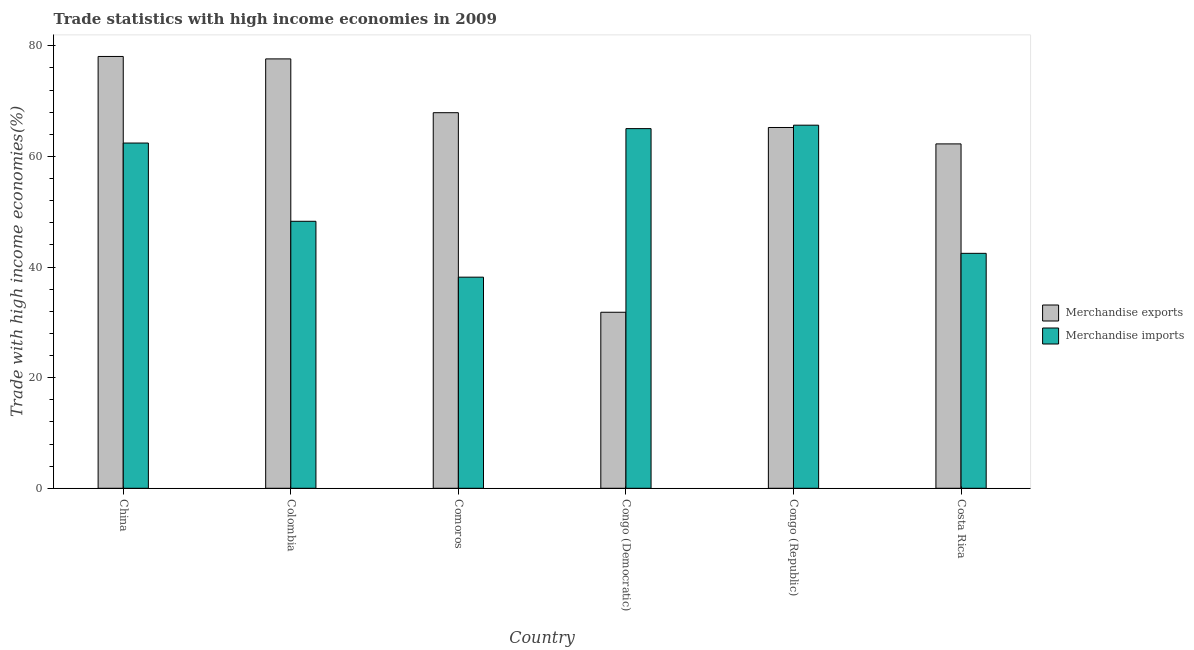How many different coloured bars are there?
Offer a very short reply. 2. How many groups of bars are there?
Your answer should be very brief. 6. Are the number of bars on each tick of the X-axis equal?
Offer a very short reply. Yes. In how many cases, is the number of bars for a given country not equal to the number of legend labels?
Offer a very short reply. 0. What is the merchandise exports in Costa Rica?
Give a very brief answer. 62.27. Across all countries, what is the maximum merchandise exports?
Make the answer very short. 78.08. Across all countries, what is the minimum merchandise imports?
Your answer should be compact. 38.18. In which country was the merchandise imports maximum?
Offer a terse response. Congo (Republic). In which country was the merchandise exports minimum?
Your answer should be very brief. Congo (Democratic). What is the total merchandise exports in the graph?
Make the answer very short. 382.99. What is the difference between the merchandise exports in Comoros and that in Congo (Republic)?
Keep it short and to the point. 2.68. What is the difference between the merchandise imports in Congo (Republic) and the merchandise exports in Comoros?
Offer a very short reply. -2.26. What is the average merchandise exports per country?
Give a very brief answer. 63.83. What is the difference between the merchandise imports and merchandise exports in Colombia?
Your answer should be compact. -29.36. What is the ratio of the merchandise imports in China to that in Comoros?
Your answer should be compact. 1.64. What is the difference between the highest and the second highest merchandise imports?
Give a very brief answer. 0.62. What is the difference between the highest and the lowest merchandise exports?
Your answer should be very brief. 46.25. In how many countries, is the merchandise imports greater than the average merchandise imports taken over all countries?
Make the answer very short. 3. What does the 2nd bar from the right in Congo (Republic) represents?
Ensure brevity in your answer.  Merchandise exports. How many bars are there?
Provide a succinct answer. 12. Are all the bars in the graph horizontal?
Your response must be concise. No. What is the difference between two consecutive major ticks on the Y-axis?
Give a very brief answer. 20. Are the values on the major ticks of Y-axis written in scientific E-notation?
Provide a succinct answer. No. Does the graph contain any zero values?
Your answer should be very brief. No. Does the graph contain grids?
Give a very brief answer. No. How are the legend labels stacked?
Provide a succinct answer. Vertical. What is the title of the graph?
Keep it short and to the point. Trade statistics with high income economies in 2009. Does "Revenue" appear as one of the legend labels in the graph?
Make the answer very short. No. What is the label or title of the X-axis?
Provide a short and direct response. Country. What is the label or title of the Y-axis?
Provide a short and direct response. Trade with high income economies(%). What is the Trade with high income economies(%) of Merchandise exports in China?
Ensure brevity in your answer.  78.08. What is the Trade with high income economies(%) of Merchandise imports in China?
Ensure brevity in your answer.  62.43. What is the Trade with high income economies(%) in Merchandise exports in Colombia?
Make the answer very short. 77.64. What is the Trade with high income economies(%) in Merchandise imports in Colombia?
Your answer should be compact. 48.28. What is the Trade with high income economies(%) in Merchandise exports in Comoros?
Your answer should be very brief. 67.92. What is the Trade with high income economies(%) of Merchandise imports in Comoros?
Your answer should be compact. 38.18. What is the Trade with high income economies(%) of Merchandise exports in Congo (Democratic)?
Make the answer very short. 31.83. What is the Trade with high income economies(%) in Merchandise imports in Congo (Democratic)?
Your answer should be very brief. 65.04. What is the Trade with high income economies(%) in Merchandise exports in Congo (Republic)?
Your answer should be compact. 65.24. What is the Trade with high income economies(%) of Merchandise imports in Congo (Republic)?
Your answer should be compact. 65.66. What is the Trade with high income economies(%) of Merchandise exports in Costa Rica?
Offer a very short reply. 62.27. What is the Trade with high income economies(%) in Merchandise imports in Costa Rica?
Keep it short and to the point. 42.48. Across all countries, what is the maximum Trade with high income economies(%) in Merchandise exports?
Provide a short and direct response. 78.08. Across all countries, what is the maximum Trade with high income economies(%) in Merchandise imports?
Provide a succinct answer. 65.66. Across all countries, what is the minimum Trade with high income economies(%) in Merchandise exports?
Ensure brevity in your answer.  31.83. Across all countries, what is the minimum Trade with high income economies(%) of Merchandise imports?
Your answer should be very brief. 38.18. What is the total Trade with high income economies(%) in Merchandise exports in the graph?
Your answer should be compact. 382.99. What is the total Trade with high income economies(%) of Merchandise imports in the graph?
Keep it short and to the point. 322.07. What is the difference between the Trade with high income economies(%) in Merchandise exports in China and that in Colombia?
Ensure brevity in your answer.  0.44. What is the difference between the Trade with high income economies(%) of Merchandise imports in China and that in Colombia?
Offer a very short reply. 14.15. What is the difference between the Trade with high income economies(%) of Merchandise exports in China and that in Comoros?
Your answer should be very brief. 10.17. What is the difference between the Trade with high income economies(%) in Merchandise imports in China and that in Comoros?
Ensure brevity in your answer.  24.25. What is the difference between the Trade with high income economies(%) in Merchandise exports in China and that in Congo (Democratic)?
Your response must be concise. 46.25. What is the difference between the Trade with high income economies(%) in Merchandise imports in China and that in Congo (Democratic)?
Ensure brevity in your answer.  -2.61. What is the difference between the Trade with high income economies(%) in Merchandise exports in China and that in Congo (Republic)?
Your answer should be very brief. 12.84. What is the difference between the Trade with high income economies(%) in Merchandise imports in China and that in Congo (Republic)?
Your response must be concise. -3.23. What is the difference between the Trade with high income economies(%) of Merchandise exports in China and that in Costa Rica?
Make the answer very short. 15.81. What is the difference between the Trade with high income economies(%) in Merchandise imports in China and that in Costa Rica?
Offer a very short reply. 19.95. What is the difference between the Trade with high income economies(%) of Merchandise exports in Colombia and that in Comoros?
Your answer should be very brief. 9.73. What is the difference between the Trade with high income economies(%) in Merchandise imports in Colombia and that in Comoros?
Make the answer very short. 10.1. What is the difference between the Trade with high income economies(%) in Merchandise exports in Colombia and that in Congo (Democratic)?
Keep it short and to the point. 45.81. What is the difference between the Trade with high income economies(%) of Merchandise imports in Colombia and that in Congo (Democratic)?
Offer a very short reply. -16.76. What is the difference between the Trade with high income economies(%) in Merchandise exports in Colombia and that in Congo (Republic)?
Your answer should be compact. 12.4. What is the difference between the Trade with high income economies(%) in Merchandise imports in Colombia and that in Congo (Republic)?
Make the answer very short. -17.38. What is the difference between the Trade with high income economies(%) of Merchandise exports in Colombia and that in Costa Rica?
Keep it short and to the point. 15.37. What is the difference between the Trade with high income economies(%) of Merchandise imports in Colombia and that in Costa Rica?
Provide a succinct answer. 5.8. What is the difference between the Trade with high income economies(%) in Merchandise exports in Comoros and that in Congo (Democratic)?
Give a very brief answer. 36.08. What is the difference between the Trade with high income economies(%) of Merchandise imports in Comoros and that in Congo (Democratic)?
Make the answer very short. -26.86. What is the difference between the Trade with high income economies(%) in Merchandise exports in Comoros and that in Congo (Republic)?
Give a very brief answer. 2.68. What is the difference between the Trade with high income economies(%) of Merchandise imports in Comoros and that in Congo (Republic)?
Give a very brief answer. -27.48. What is the difference between the Trade with high income economies(%) of Merchandise exports in Comoros and that in Costa Rica?
Your answer should be compact. 5.64. What is the difference between the Trade with high income economies(%) of Merchandise imports in Comoros and that in Costa Rica?
Your response must be concise. -4.31. What is the difference between the Trade with high income economies(%) of Merchandise exports in Congo (Democratic) and that in Congo (Republic)?
Your answer should be compact. -33.41. What is the difference between the Trade with high income economies(%) in Merchandise imports in Congo (Democratic) and that in Congo (Republic)?
Provide a succinct answer. -0.62. What is the difference between the Trade with high income economies(%) in Merchandise exports in Congo (Democratic) and that in Costa Rica?
Your answer should be compact. -30.44. What is the difference between the Trade with high income economies(%) in Merchandise imports in Congo (Democratic) and that in Costa Rica?
Offer a very short reply. 22.55. What is the difference between the Trade with high income economies(%) of Merchandise exports in Congo (Republic) and that in Costa Rica?
Your answer should be very brief. 2.97. What is the difference between the Trade with high income economies(%) in Merchandise imports in Congo (Republic) and that in Costa Rica?
Offer a terse response. 23.18. What is the difference between the Trade with high income economies(%) of Merchandise exports in China and the Trade with high income economies(%) of Merchandise imports in Colombia?
Ensure brevity in your answer.  29.8. What is the difference between the Trade with high income economies(%) of Merchandise exports in China and the Trade with high income economies(%) of Merchandise imports in Comoros?
Your response must be concise. 39.91. What is the difference between the Trade with high income economies(%) in Merchandise exports in China and the Trade with high income economies(%) in Merchandise imports in Congo (Democratic)?
Make the answer very short. 13.05. What is the difference between the Trade with high income economies(%) of Merchandise exports in China and the Trade with high income economies(%) of Merchandise imports in Congo (Republic)?
Keep it short and to the point. 12.43. What is the difference between the Trade with high income economies(%) in Merchandise exports in China and the Trade with high income economies(%) in Merchandise imports in Costa Rica?
Make the answer very short. 35.6. What is the difference between the Trade with high income economies(%) in Merchandise exports in Colombia and the Trade with high income economies(%) in Merchandise imports in Comoros?
Keep it short and to the point. 39.47. What is the difference between the Trade with high income economies(%) of Merchandise exports in Colombia and the Trade with high income economies(%) of Merchandise imports in Congo (Democratic)?
Provide a short and direct response. 12.61. What is the difference between the Trade with high income economies(%) in Merchandise exports in Colombia and the Trade with high income economies(%) in Merchandise imports in Congo (Republic)?
Make the answer very short. 11.99. What is the difference between the Trade with high income economies(%) of Merchandise exports in Colombia and the Trade with high income economies(%) of Merchandise imports in Costa Rica?
Make the answer very short. 35.16. What is the difference between the Trade with high income economies(%) in Merchandise exports in Comoros and the Trade with high income economies(%) in Merchandise imports in Congo (Democratic)?
Keep it short and to the point. 2.88. What is the difference between the Trade with high income economies(%) in Merchandise exports in Comoros and the Trade with high income economies(%) in Merchandise imports in Congo (Republic)?
Provide a short and direct response. 2.26. What is the difference between the Trade with high income economies(%) in Merchandise exports in Comoros and the Trade with high income economies(%) in Merchandise imports in Costa Rica?
Your answer should be compact. 25.43. What is the difference between the Trade with high income economies(%) in Merchandise exports in Congo (Democratic) and the Trade with high income economies(%) in Merchandise imports in Congo (Republic)?
Offer a terse response. -33.83. What is the difference between the Trade with high income economies(%) in Merchandise exports in Congo (Democratic) and the Trade with high income economies(%) in Merchandise imports in Costa Rica?
Provide a short and direct response. -10.65. What is the difference between the Trade with high income economies(%) in Merchandise exports in Congo (Republic) and the Trade with high income economies(%) in Merchandise imports in Costa Rica?
Your answer should be compact. 22.76. What is the average Trade with high income economies(%) of Merchandise exports per country?
Make the answer very short. 63.83. What is the average Trade with high income economies(%) in Merchandise imports per country?
Give a very brief answer. 53.68. What is the difference between the Trade with high income economies(%) in Merchandise exports and Trade with high income economies(%) in Merchandise imports in China?
Your response must be concise. 15.65. What is the difference between the Trade with high income economies(%) of Merchandise exports and Trade with high income economies(%) of Merchandise imports in Colombia?
Provide a succinct answer. 29.36. What is the difference between the Trade with high income economies(%) in Merchandise exports and Trade with high income economies(%) in Merchandise imports in Comoros?
Offer a very short reply. 29.74. What is the difference between the Trade with high income economies(%) in Merchandise exports and Trade with high income economies(%) in Merchandise imports in Congo (Democratic)?
Your response must be concise. -33.21. What is the difference between the Trade with high income economies(%) in Merchandise exports and Trade with high income economies(%) in Merchandise imports in Congo (Republic)?
Keep it short and to the point. -0.42. What is the difference between the Trade with high income economies(%) of Merchandise exports and Trade with high income economies(%) of Merchandise imports in Costa Rica?
Provide a succinct answer. 19.79. What is the ratio of the Trade with high income economies(%) in Merchandise imports in China to that in Colombia?
Your response must be concise. 1.29. What is the ratio of the Trade with high income economies(%) of Merchandise exports in China to that in Comoros?
Provide a short and direct response. 1.15. What is the ratio of the Trade with high income economies(%) of Merchandise imports in China to that in Comoros?
Offer a very short reply. 1.64. What is the ratio of the Trade with high income economies(%) in Merchandise exports in China to that in Congo (Democratic)?
Provide a succinct answer. 2.45. What is the ratio of the Trade with high income economies(%) in Merchandise imports in China to that in Congo (Democratic)?
Your answer should be very brief. 0.96. What is the ratio of the Trade with high income economies(%) of Merchandise exports in China to that in Congo (Republic)?
Provide a succinct answer. 1.2. What is the ratio of the Trade with high income economies(%) of Merchandise imports in China to that in Congo (Republic)?
Offer a very short reply. 0.95. What is the ratio of the Trade with high income economies(%) in Merchandise exports in China to that in Costa Rica?
Offer a very short reply. 1.25. What is the ratio of the Trade with high income economies(%) in Merchandise imports in China to that in Costa Rica?
Make the answer very short. 1.47. What is the ratio of the Trade with high income economies(%) in Merchandise exports in Colombia to that in Comoros?
Provide a succinct answer. 1.14. What is the ratio of the Trade with high income economies(%) of Merchandise imports in Colombia to that in Comoros?
Provide a short and direct response. 1.26. What is the ratio of the Trade with high income economies(%) in Merchandise exports in Colombia to that in Congo (Democratic)?
Ensure brevity in your answer.  2.44. What is the ratio of the Trade with high income economies(%) in Merchandise imports in Colombia to that in Congo (Democratic)?
Give a very brief answer. 0.74. What is the ratio of the Trade with high income economies(%) of Merchandise exports in Colombia to that in Congo (Republic)?
Provide a short and direct response. 1.19. What is the ratio of the Trade with high income economies(%) in Merchandise imports in Colombia to that in Congo (Republic)?
Offer a terse response. 0.74. What is the ratio of the Trade with high income economies(%) in Merchandise exports in Colombia to that in Costa Rica?
Provide a succinct answer. 1.25. What is the ratio of the Trade with high income economies(%) in Merchandise imports in Colombia to that in Costa Rica?
Make the answer very short. 1.14. What is the ratio of the Trade with high income economies(%) in Merchandise exports in Comoros to that in Congo (Democratic)?
Make the answer very short. 2.13. What is the ratio of the Trade with high income economies(%) in Merchandise imports in Comoros to that in Congo (Democratic)?
Ensure brevity in your answer.  0.59. What is the ratio of the Trade with high income economies(%) in Merchandise exports in Comoros to that in Congo (Republic)?
Your answer should be very brief. 1.04. What is the ratio of the Trade with high income economies(%) of Merchandise imports in Comoros to that in Congo (Republic)?
Your answer should be very brief. 0.58. What is the ratio of the Trade with high income economies(%) of Merchandise exports in Comoros to that in Costa Rica?
Provide a short and direct response. 1.09. What is the ratio of the Trade with high income economies(%) of Merchandise imports in Comoros to that in Costa Rica?
Your response must be concise. 0.9. What is the ratio of the Trade with high income economies(%) in Merchandise exports in Congo (Democratic) to that in Congo (Republic)?
Give a very brief answer. 0.49. What is the ratio of the Trade with high income economies(%) in Merchandise imports in Congo (Democratic) to that in Congo (Republic)?
Offer a very short reply. 0.99. What is the ratio of the Trade with high income economies(%) of Merchandise exports in Congo (Democratic) to that in Costa Rica?
Your response must be concise. 0.51. What is the ratio of the Trade with high income economies(%) in Merchandise imports in Congo (Democratic) to that in Costa Rica?
Your answer should be very brief. 1.53. What is the ratio of the Trade with high income economies(%) in Merchandise exports in Congo (Republic) to that in Costa Rica?
Your answer should be compact. 1.05. What is the ratio of the Trade with high income economies(%) in Merchandise imports in Congo (Republic) to that in Costa Rica?
Provide a succinct answer. 1.55. What is the difference between the highest and the second highest Trade with high income economies(%) of Merchandise exports?
Provide a short and direct response. 0.44. What is the difference between the highest and the second highest Trade with high income economies(%) of Merchandise imports?
Your answer should be very brief. 0.62. What is the difference between the highest and the lowest Trade with high income economies(%) of Merchandise exports?
Give a very brief answer. 46.25. What is the difference between the highest and the lowest Trade with high income economies(%) in Merchandise imports?
Offer a very short reply. 27.48. 